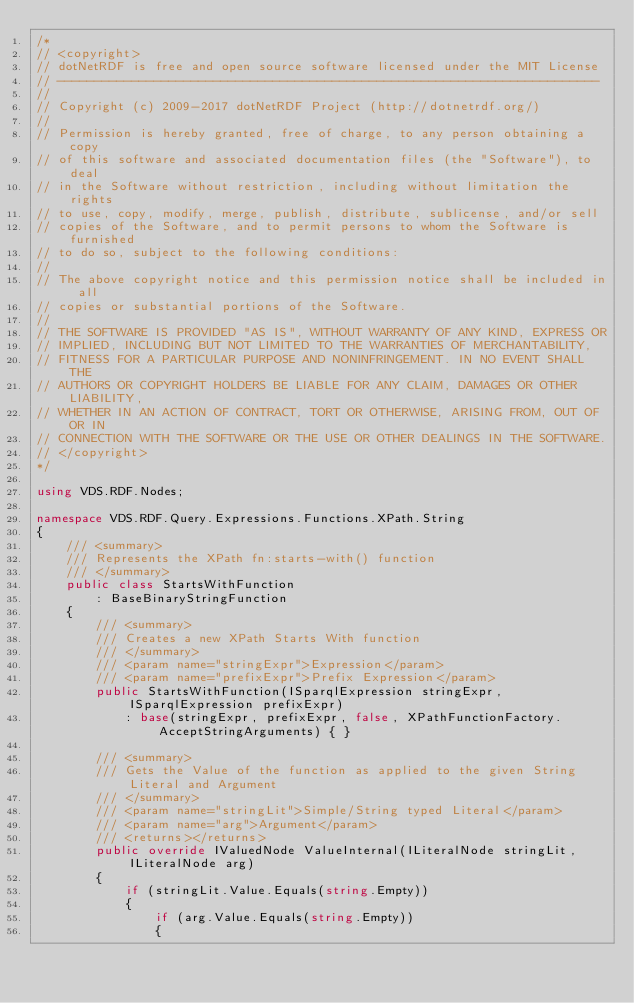Convert code to text. <code><loc_0><loc_0><loc_500><loc_500><_C#_>/*
// <copyright>
// dotNetRDF is free and open source software licensed under the MIT License
// -------------------------------------------------------------------------
// 
// Copyright (c) 2009-2017 dotNetRDF Project (http://dotnetrdf.org/)
// 
// Permission is hereby granted, free of charge, to any person obtaining a copy
// of this software and associated documentation files (the "Software"), to deal
// in the Software without restriction, including without limitation the rights
// to use, copy, modify, merge, publish, distribute, sublicense, and/or sell
// copies of the Software, and to permit persons to whom the Software is furnished
// to do so, subject to the following conditions:
// 
// The above copyright notice and this permission notice shall be included in all
// copies or substantial portions of the Software.
// 
// THE SOFTWARE IS PROVIDED "AS IS", WITHOUT WARRANTY OF ANY KIND, EXPRESS OR 
// IMPLIED, INCLUDING BUT NOT LIMITED TO THE WARRANTIES OF MERCHANTABILITY, 
// FITNESS FOR A PARTICULAR PURPOSE AND NONINFRINGEMENT. IN NO EVENT SHALL THE
// AUTHORS OR COPYRIGHT HOLDERS BE LIABLE FOR ANY CLAIM, DAMAGES OR OTHER LIABILITY,
// WHETHER IN AN ACTION OF CONTRACT, TORT OR OTHERWISE, ARISING FROM, OUT OF OR IN
// CONNECTION WITH THE SOFTWARE OR THE USE OR OTHER DEALINGS IN THE SOFTWARE.
// </copyright>
*/

using VDS.RDF.Nodes;

namespace VDS.RDF.Query.Expressions.Functions.XPath.String
{
    /// <summary>
    /// Represents the XPath fn:starts-with() function
    /// </summary>
    public class StartsWithFunction
        : BaseBinaryStringFunction
    {
        /// <summary>
        /// Creates a new XPath Starts With function
        /// </summary>
        /// <param name="stringExpr">Expression</param>
        /// <param name="prefixExpr">Prefix Expression</param>
        public StartsWithFunction(ISparqlExpression stringExpr, ISparqlExpression prefixExpr)
            : base(stringExpr, prefixExpr, false, XPathFunctionFactory.AcceptStringArguments) { }

        /// <summary>
        /// Gets the Value of the function as applied to the given String Literal and Argument
        /// </summary>
        /// <param name="stringLit">Simple/String typed Literal</param>
        /// <param name="arg">Argument</param>
        /// <returns></returns>
        public override IValuedNode ValueInternal(ILiteralNode stringLit, ILiteralNode arg)
        {
            if (stringLit.Value.Equals(string.Empty))
            {
                if (arg.Value.Equals(string.Empty))
                {</code> 